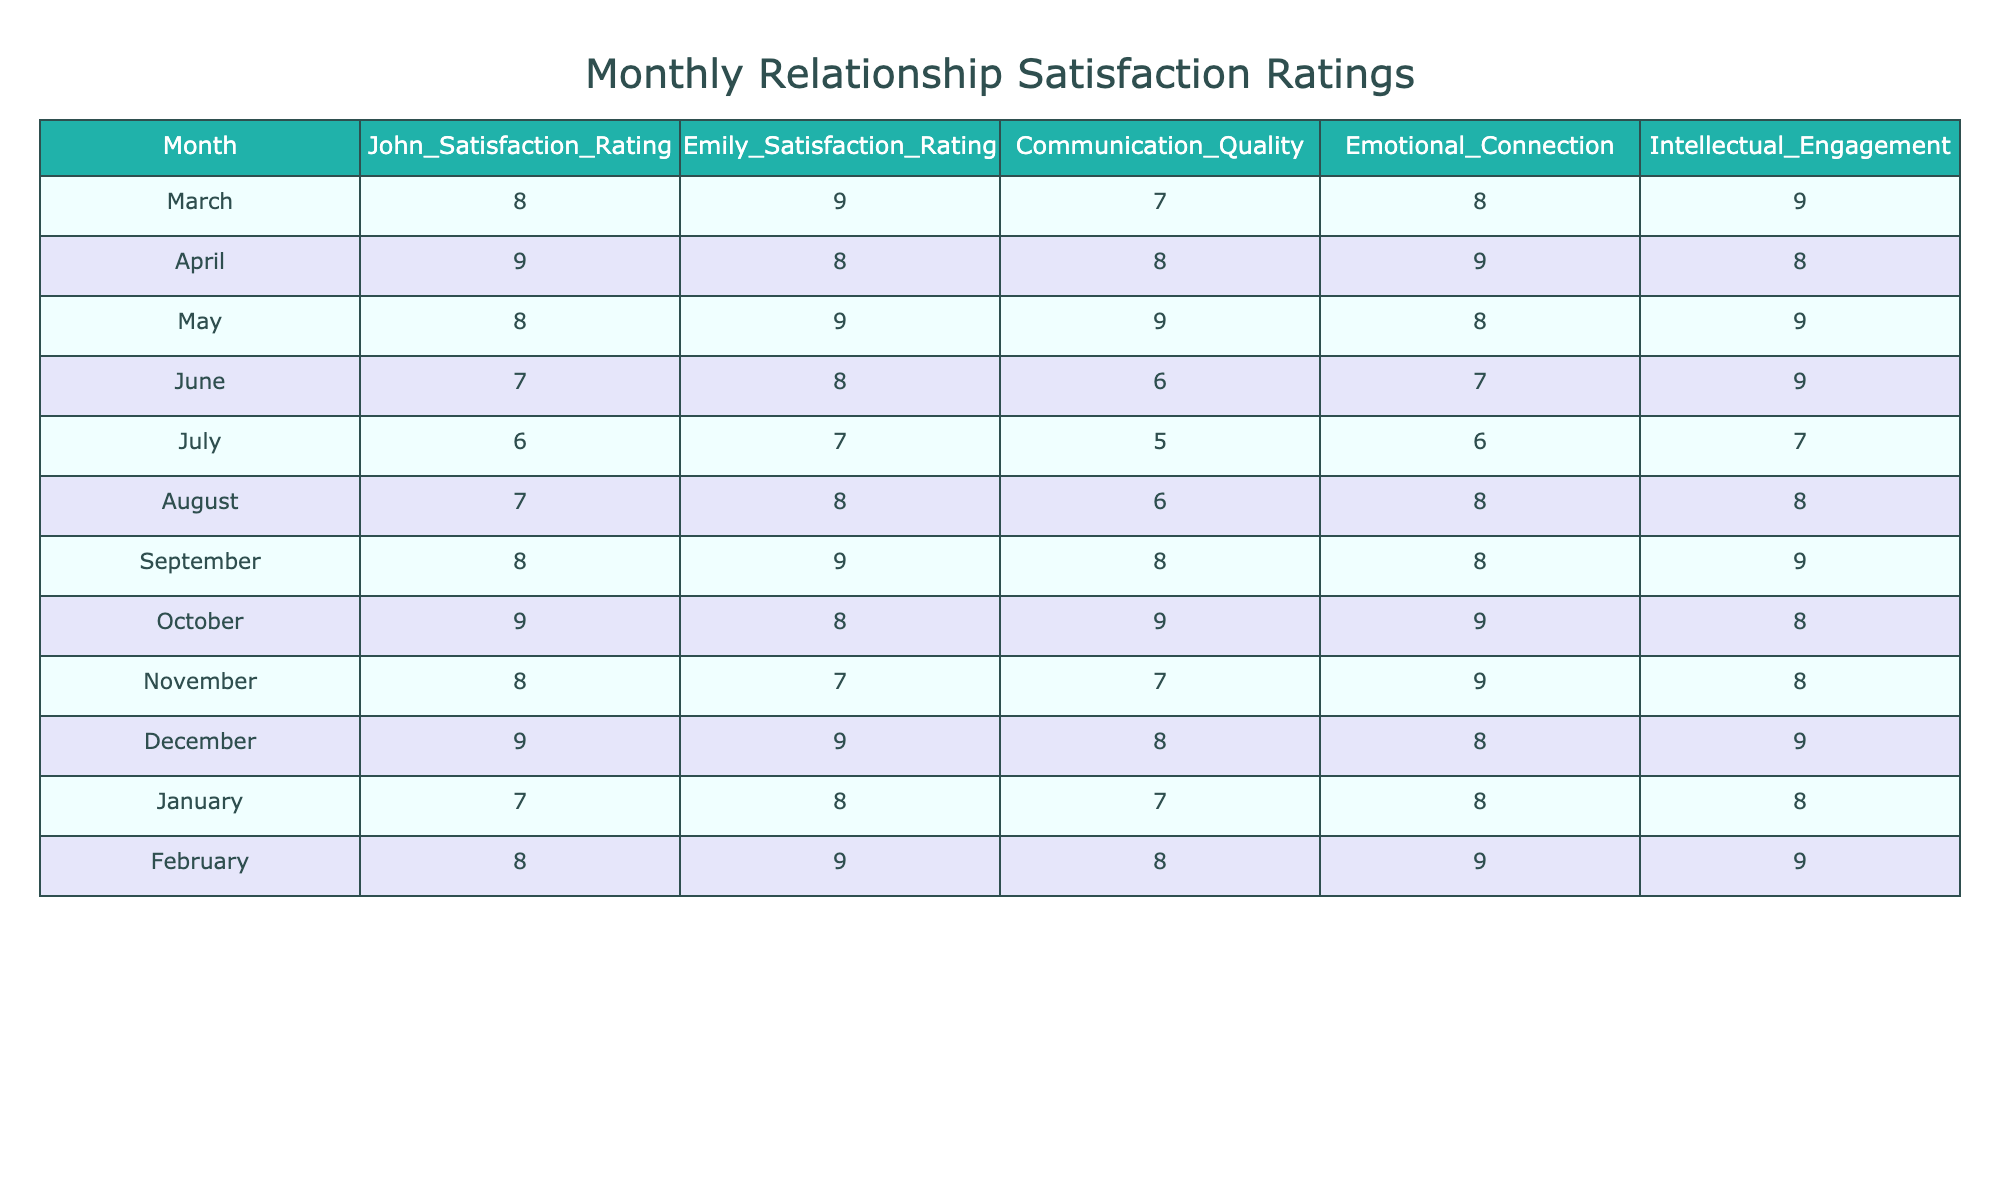What was John’s highest satisfaction rating during Summer? In the Summer months (June, July, August), John's ratings were 7, 6, and 7 respectively. The highest rating is 7, which occurred in both June and August.
Answer: 7 What is Emily’s average satisfaction rating across all seasons? Emily's ratings are 9, 8, 9, 8, 7, 8, 9, 8, 7, 9, 8, and 9 totaling 101. There are 12 months, so the average is 101/12 = 8.42.
Answer: 8.42 Was there a month when both John and Emily rated their satisfaction as 9? In December, both John and Emily rated their satisfaction as 9. Therefore, there was a month where both rated a 9.
Answer: Yes Which season had the lowest combined satisfaction ratings for John and Emily in November? In November, John's rating is 8 and Emily's rating is 7. The combined satisfaction is 8 + 7 = 15, which is the lowest combined score in any month of any season.
Answer: 15 What is the difference in satisfaction ratings between John and Emily in January? In January, John rated his satisfaction as 7, and Emily rated it as 8. The difference is 8 - 7 = 1.
Answer: 1 Which month had the highest communication quality score, and what was that score? Reviewing the communication quality for each month, the highest score is 9, which occurred in May and October.
Answer: 9 In which season did John experience the highest range of satisfaction ratings? John's satisfaction ratings were 9 (April), 8 (March), and 6 (July) in Spring and Summer, respectively. The range is highest in Summer (7-6 = 1), while in Spring (9-8 = 1). Thus, both seasons have the same range.
Answer: Spring and Summer What was the average emotional connection rating in Autumn? The emotional connection ratings in Autumn (8, 9, and 9) sum to 26. The average is 26/3 = 8.67.
Answer: 8.67 Did John or Emily generally have higher satisfaction ratings in Spring? John's ratings in Spring were 8, 9, and 8 (average 8.33), while Emily's were 9, 8, and 9 (average 8.67). Emily generally had higher ratings in Spring.
Answer: Emily What season had the least variation in intellectual engagement ratings? The intellectual engagement ratings across the seasons were 9, 8, 9 in Spring; 9, 7, 8 in Summer; 9, 8, 8 in Autumn; and 9, 8, 9 in Winter. The smallest range is in both Autumn and Winter (1).
Answer: Autumn and Winter 